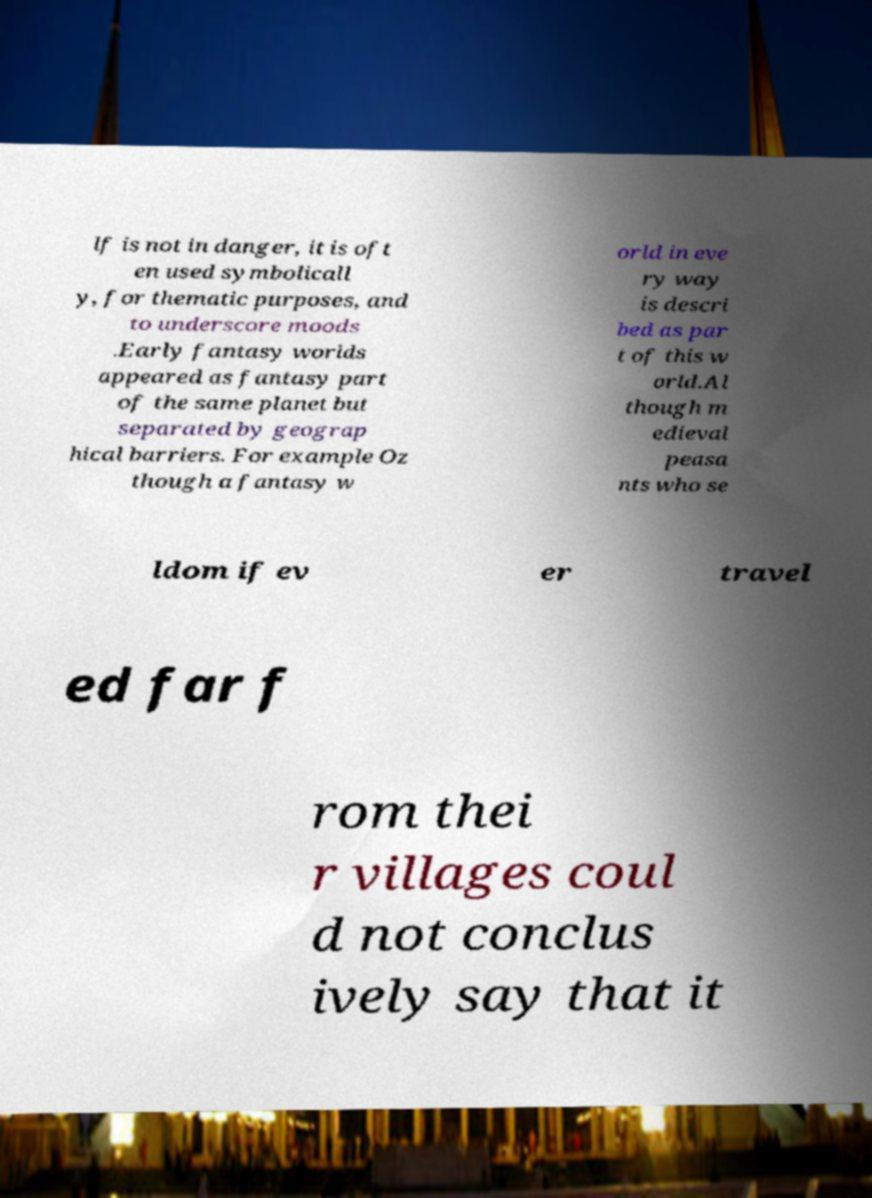Can you read and provide the text displayed in the image?This photo seems to have some interesting text. Can you extract and type it out for me? lf is not in danger, it is oft en used symbolicall y, for thematic purposes, and to underscore moods .Early fantasy worlds appeared as fantasy part of the same planet but separated by geograp hical barriers. For example Oz though a fantasy w orld in eve ry way is descri bed as par t of this w orld.Al though m edieval peasa nts who se ldom if ev er travel ed far f rom thei r villages coul d not conclus ively say that it 